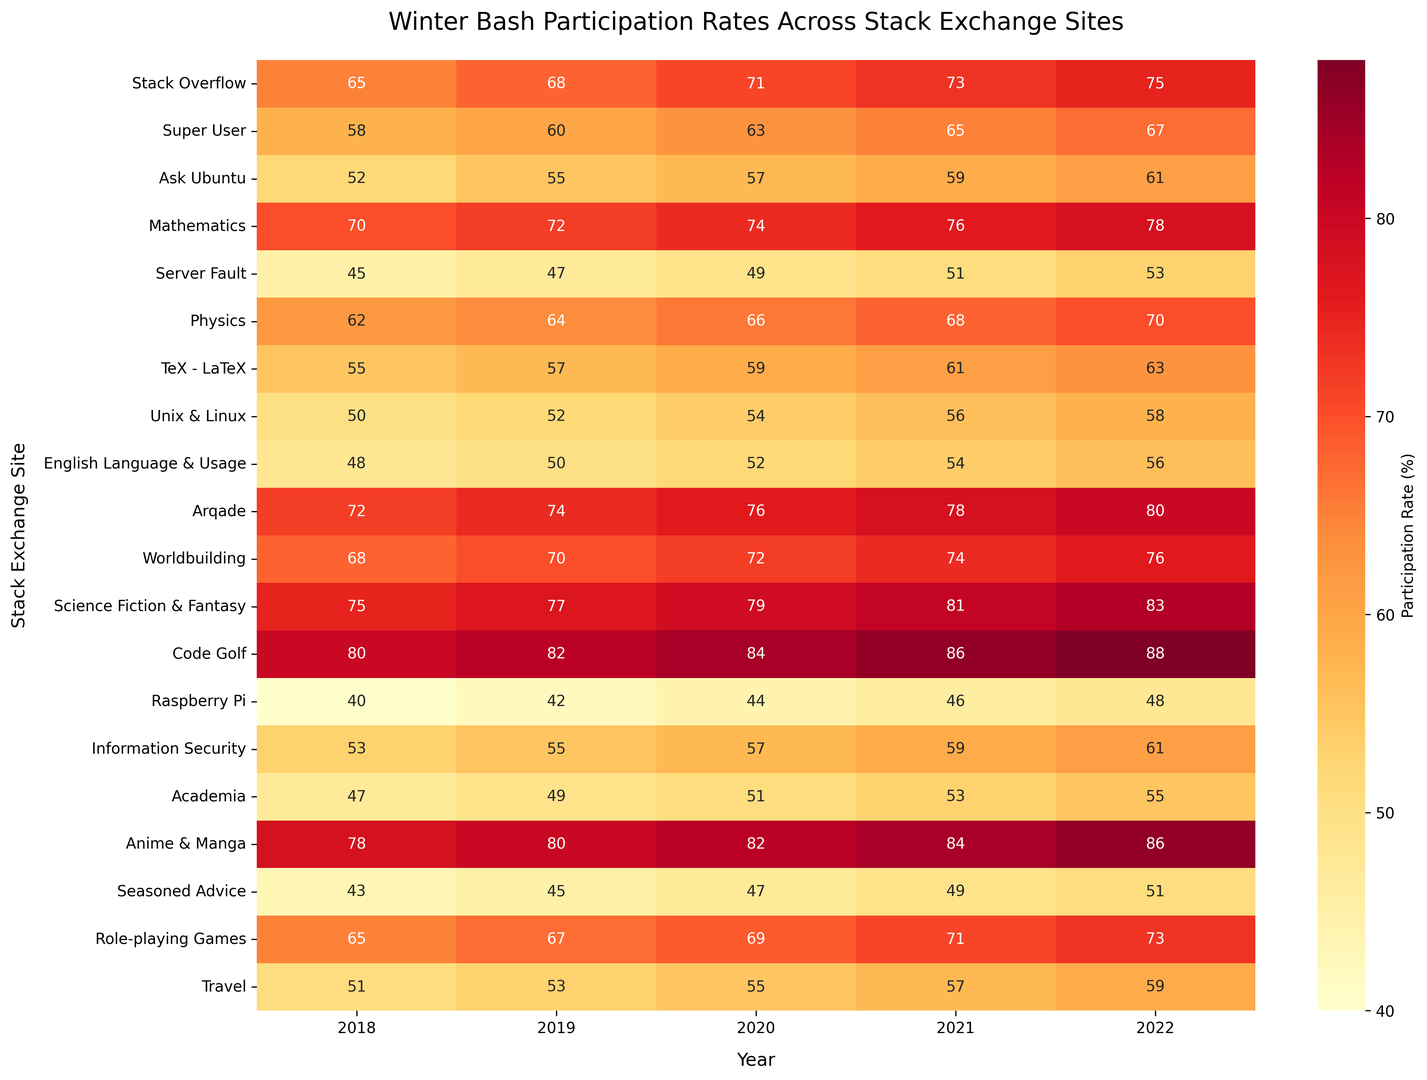What's the site with the highest participation rate in 2022? Look at the column corresponding to 2022 and find the highest number. The highest number is 88, which corresponds to the Code Golf site.
Answer: Code Golf Which site had the lowest participation rate in 2018? Look at the column corresponding to 2018 and find the lowest number. The lowest number is 40, which corresponds to the Raspberry Pi site.
Answer: Raspberry Pi How has the participation rate in "Science Fiction & Fantasy" changed from 2018 to 2022? Look at the row for Science Fiction & Fantasy and note the values from 2018 to 2022. In 2018 it was 75, and in 2022 it was 83. The participation rate increased.
Answer: Increased Which two sites had the closest participation rates in 2021? Compare the values in the 2021 column and find the two sites with the smallest difference in values. "Super User" had 65 and "Role-playing Games" had 71, giving a difference of 6. "Ask Ubuntu" had 59 and "TeX - LaTeX" had 61, giving a difference of 2, which is the smallest. So "Ask Ubuntu" and "TeX - LaTeX" had the closest rates.
Answer: Ask Ubuntu and TeX - LaTeX Which years had the highest increase in participation for "Worldbuilding"? Look at the row for "Worldbuilding" and compare the differences between consecutive years. The differences are 68 to 70 (2), 70 to 72 (2), 72 to 74 (2), and 74 to 76 (2). Each yearly increase is the same, so all years have equal increases.
Answer: All years What is the average participation rate for "Academia" from 2018 to 2022? Add up the participation rates for each year in "Academia" and divide by the number of years. The values are 47, 49, 51, 53, and 55. Sum these to get 255. Divide by 5 to get the average: 255 / 5 = 51.
Answer: 51 Which site had consistently increasing participation rates each year from 2018 to 2022? Look at the rows for every site and check for consistently increasing values each year. All the sites listed have consistently increasing participation rates.
Answer: All sites Among the listed Stack Exchange sites, which had the third-highest participation rate in 2019? Sort the participation rates in the 2019 column in descending order. The column shows 82 (Code Golf), 80 (Anime & Manga), and 77 (Science Fiction & Fantasy), so "Science Fiction & Fantasy" had the third-highest rate in 2019.
Answer: Science Fiction & Fantasy Which site had greater participation in 2020: "Super User" or "Mathematics"? Compare the values for "Super User" and "Mathematics" in the 2020 column. "Super User" had 63, while "Mathematics" had 74. 74 is greater than 63, so "Mathematics" had greater participation.
Answer: Mathematics 